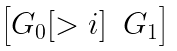Convert formula to latex. <formula><loc_0><loc_0><loc_500><loc_500>\begin{bmatrix} G _ { 0 } [ > i ] & G _ { 1 } \end{bmatrix}</formula> 